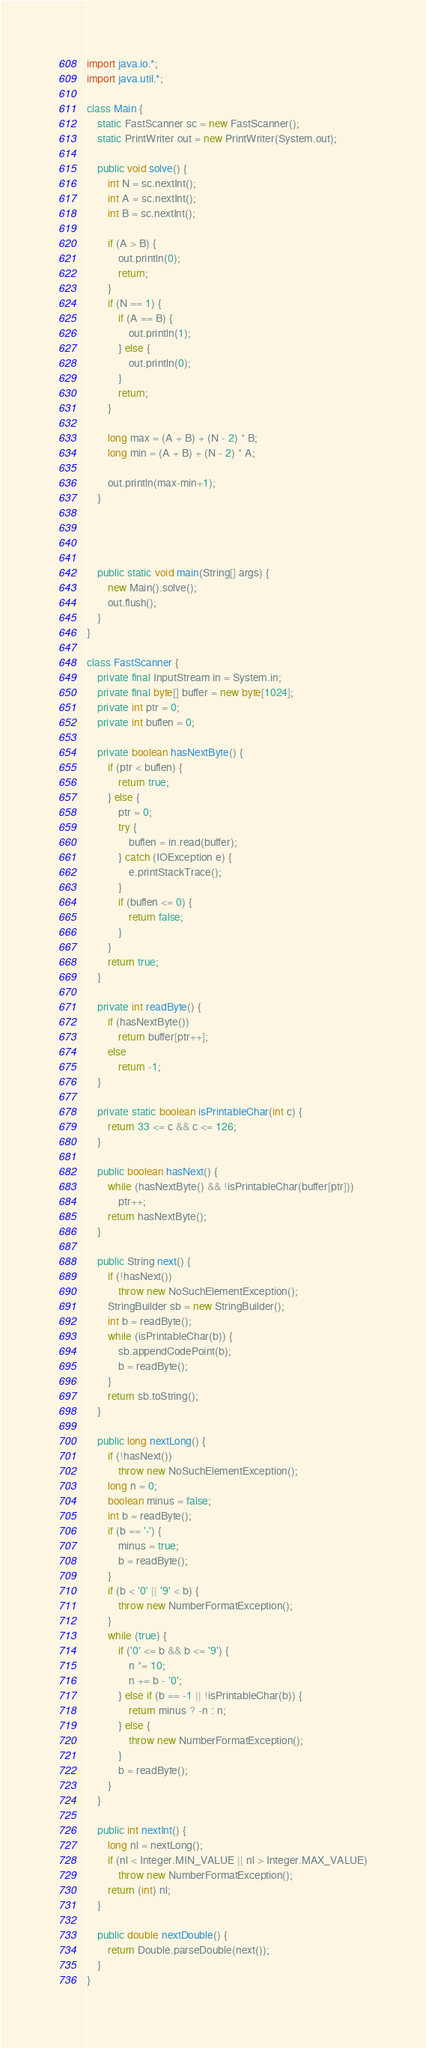Convert code to text. <code><loc_0><loc_0><loc_500><loc_500><_Java_>import java.io.*;
import java.util.*;

class Main {
	static FastScanner sc = new FastScanner();
	static PrintWriter out = new PrintWriter(System.out);

	public void solve() {
		int N = sc.nextInt();
		int A = sc.nextInt();
		int B = sc.nextInt();

		if (A > B) {
			out.println(0);
			return;
		}
		if (N == 1) {
			if (A == B) {
				out.println(1);
			} else {
				out.println(0);
			}
			return;
		}

		long max = (A + B) + (N - 2) * B;
		long min = (A + B) + (N - 2) * A;

		out.println(max-min+1);
	}




	public static void main(String[] args) {
		new Main().solve();
		out.flush();
	}
}

class FastScanner {
	private final InputStream in = System.in;
	private final byte[] buffer = new byte[1024];
	private int ptr = 0;
	private int buflen = 0;

	private boolean hasNextByte() {
		if (ptr < buflen) {
			return true;
		} else {
			ptr = 0;
			try {
				buflen = in.read(buffer);
			} catch (IOException e) {
				e.printStackTrace();
			}
			if (buflen <= 0) {
				return false;
			}
		}
		return true;
	}

	private int readByte() {
		if (hasNextByte())
			return buffer[ptr++];
		else
			return -1;
	}

	private static boolean isPrintableChar(int c) {
		return 33 <= c && c <= 126;
	}

	public boolean hasNext() {
		while (hasNextByte() && !isPrintableChar(buffer[ptr]))
			ptr++;
		return hasNextByte();
	}

	public String next() {
		if (!hasNext())
			throw new NoSuchElementException();
		StringBuilder sb = new StringBuilder();
		int b = readByte();
		while (isPrintableChar(b)) {
			sb.appendCodePoint(b);
			b = readByte();
		}
		return sb.toString();
	}

	public long nextLong() {
		if (!hasNext())
			throw new NoSuchElementException();
		long n = 0;
		boolean minus = false;
		int b = readByte();
		if (b == '-') {
			minus = true;
			b = readByte();
		}
		if (b < '0' || '9' < b) {
			throw new NumberFormatException();
		}
		while (true) {
			if ('0' <= b && b <= '9') {
				n *= 10;
				n += b - '0';
			} else if (b == -1 || !isPrintableChar(b)) {
				return minus ? -n : n;
			} else {
				throw new NumberFormatException();
			}
			b = readByte();
		}
	}

	public int nextInt() {
		long nl = nextLong();
		if (nl < Integer.MIN_VALUE || nl > Integer.MAX_VALUE)
			throw new NumberFormatException();
		return (int) nl;
	}

	public double nextDouble() {
		return Double.parseDouble(next());
	}
}
</code> 